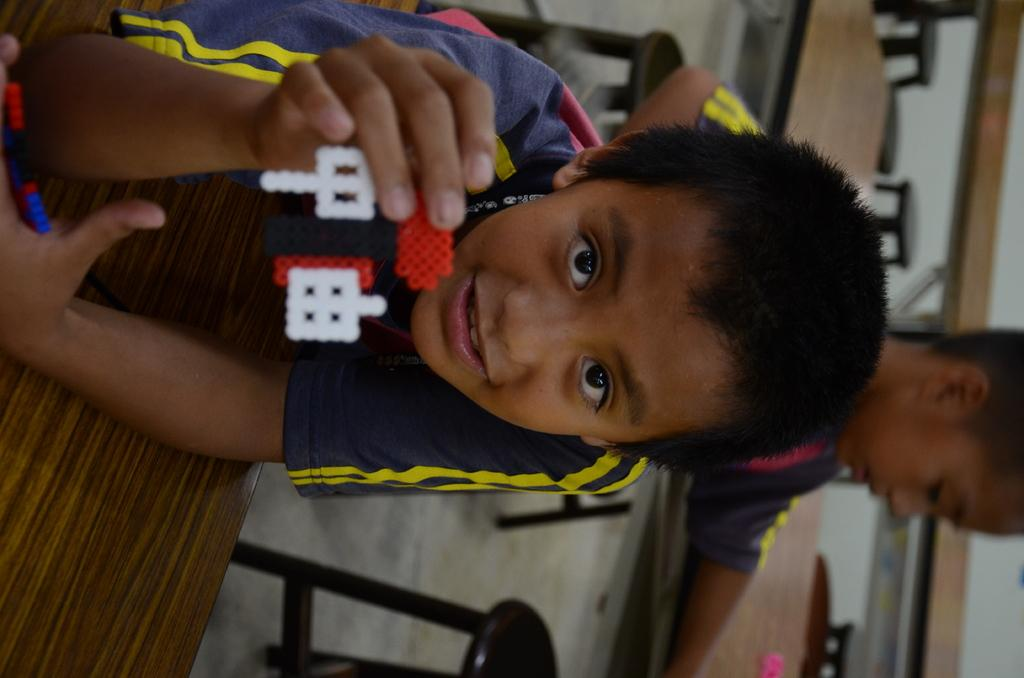Who is the main subject in the image? There is a boy in the image. What is the boy wearing? The boy is wearing a dark blue and yellow t-shirt. What is the boy holding in his hand? The boy is holding a toy in his hand. Are there any other people in the image? Yes, there is another boy present in the image. What type of furniture can be seen in the image? Tables are visible in the image. How many sheep are present in the image? There are no sheep present in the image. What type of industry is depicted in the image? There is no industry depicted in the image. 